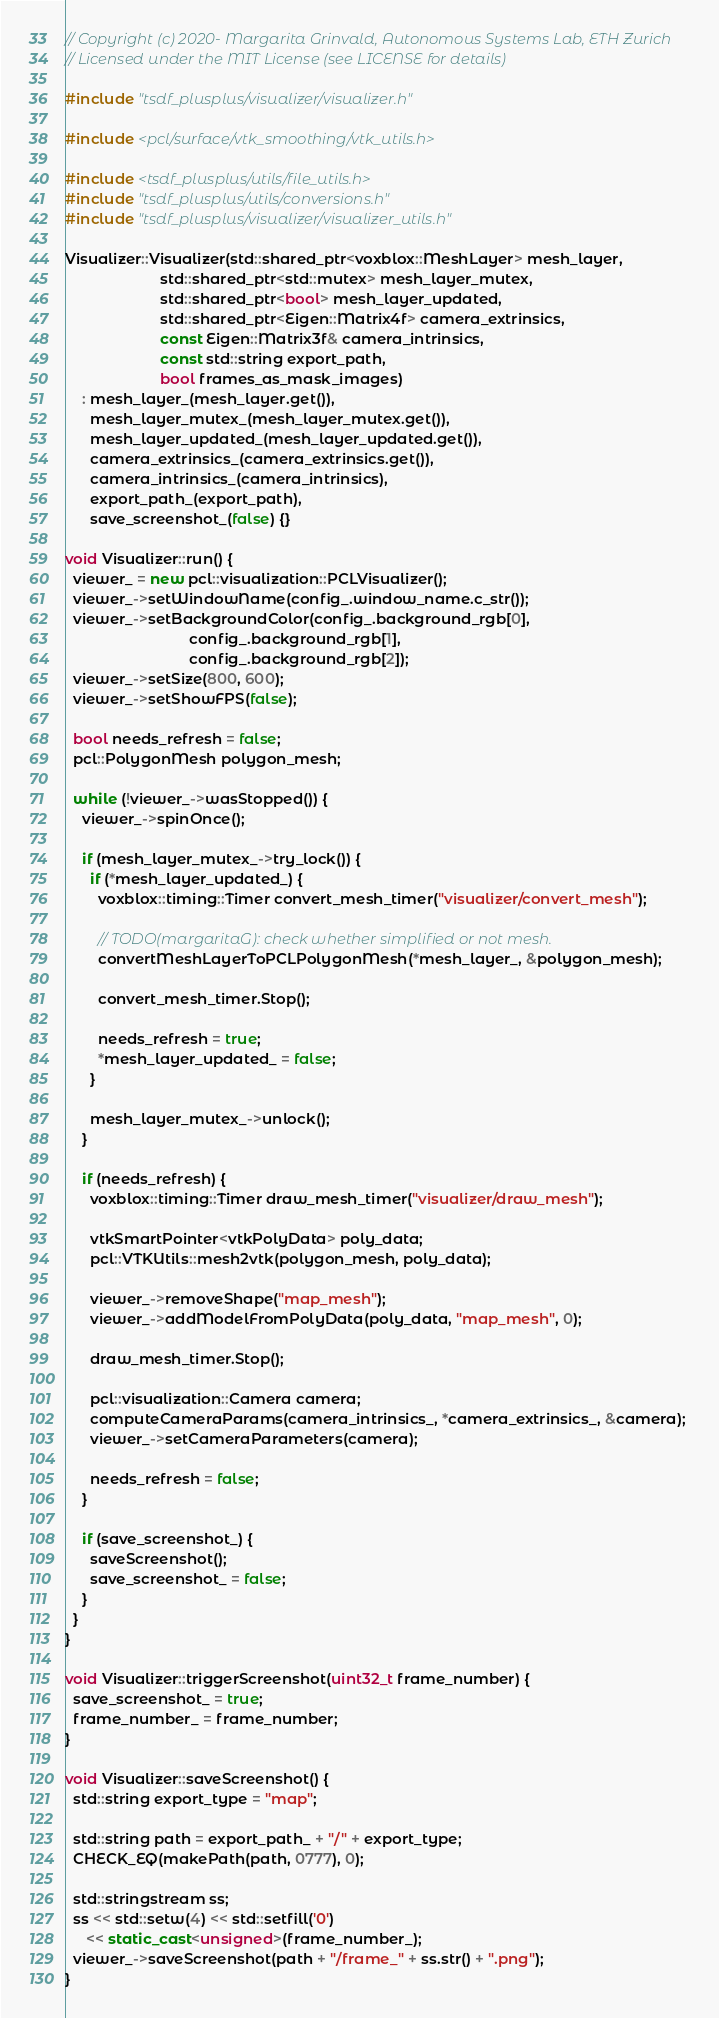Convert code to text. <code><loc_0><loc_0><loc_500><loc_500><_C++_>// Copyright (c) 2020- Margarita Grinvald, Autonomous Systems Lab, ETH Zurich
// Licensed under the MIT License (see LICENSE for details)

#include "tsdf_plusplus/visualizer/visualizer.h"

#include <pcl/surface/vtk_smoothing/vtk_utils.h>

#include <tsdf_plusplus/utils/file_utils.h>
#include "tsdf_plusplus/utils/conversions.h"
#include "tsdf_plusplus/visualizer/visualizer_utils.h"

Visualizer::Visualizer(std::shared_ptr<voxblox::MeshLayer> mesh_layer,
                       std::shared_ptr<std::mutex> mesh_layer_mutex,
                       std::shared_ptr<bool> mesh_layer_updated,
                       std::shared_ptr<Eigen::Matrix4f> camera_extrinsics,
                       const Eigen::Matrix3f& camera_intrinsics,
                       const std::string export_path,
                       bool frames_as_mask_images)
    : mesh_layer_(mesh_layer.get()),
      mesh_layer_mutex_(mesh_layer_mutex.get()),
      mesh_layer_updated_(mesh_layer_updated.get()),
      camera_extrinsics_(camera_extrinsics.get()),
      camera_intrinsics_(camera_intrinsics),
      export_path_(export_path),
      save_screenshot_(false) {}

void Visualizer::run() {
  viewer_ = new pcl::visualization::PCLVisualizer();
  viewer_->setWindowName(config_.window_name.c_str());
  viewer_->setBackgroundColor(config_.background_rgb[0],
                              config_.background_rgb[1],
                              config_.background_rgb[2]);
  viewer_->setSize(800, 600);
  viewer_->setShowFPS(false);

  bool needs_refresh = false;
  pcl::PolygonMesh polygon_mesh;

  while (!viewer_->wasStopped()) {
    viewer_->spinOnce();

    if (mesh_layer_mutex_->try_lock()) {
      if (*mesh_layer_updated_) {
        voxblox::timing::Timer convert_mesh_timer("visualizer/convert_mesh");

        // TODO(margaritaG): check whether simplified or not mesh.
        convertMeshLayerToPCLPolygonMesh(*mesh_layer_, &polygon_mesh);

        convert_mesh_timer.Stop();

        needs_refresh = true;
        *mesh_layer_updated_ = false;
      }

      mesh_layer_mutex_->unlock();
    }

    if (needs_refresh) {
      voxblox::timing::Timer draw_mesh_timer("visualizer/draw_mesh");

      vtkSmartPointer<vtkPolyData> poly_data;
      pcl::VTKUtils::mesh2vtk(polygon_mesh, poly_data);

      viewer_->removeShape("map_mesh");
      viewer_->addModelFromPolyData(poly_data, "map_mesh", 0);

      draw_mesh_timer.Stop();

      pcl::visualization::Camera camera;
      computeCameraParams(camera_intrinsics_, *camera_extrinsics_, &camera);
      viewer_->setCameraParameters(camera);

      needs_refresh = false;
    }

    if (save_screenshot_) {
      saveScreenshot();
      save_screenshot_ = false;
    }
  }
}

void Visualizer::triggerScreenshot(uint32_t frame_number) {
  save_screenshot_ = true;
  frame_number_ = frame_number;
}

void Visualizer::saveScreenshot() {
  std::string export_type = "map";

  std::string path = export_path_ + "/" + export_type;
  CHECK_EQ(makePath(path, 0777), 0);

  std::stringstream ss;
  ss << std::setw(4) << std::setfill('0')
     << static_cast<unsigned>(frame_number_);
  viewer_->saveScreenshot(path + "/frame_" + ss.str() + ".png");
}
</code> 